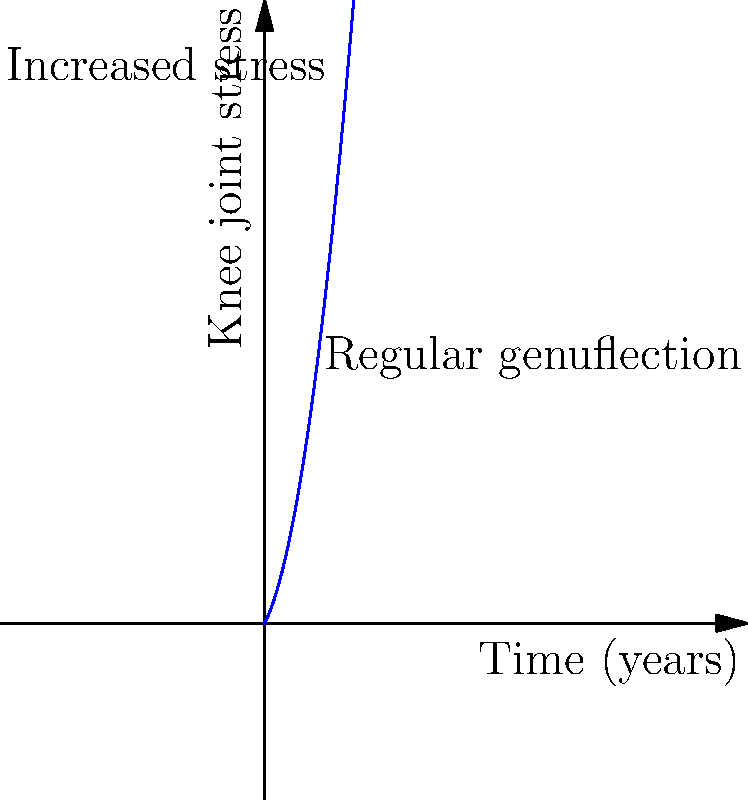Given the biomechanical stress curve of knee joints over time for individuals who regularly practice genuflection, what cognitive evolutionary explanation might account for the persistence of this potentially harmful religious practice? To answer this question, we need to consider several factors:

1. Biomechanical impact: The graph shows an increasing stress on knee joints over time due to regular genuflection. This suggests a potentially harmful physical effect.

2. Cognitive evolution: Despite the physical stress, the practice persists, indicating a possible evolutionary advantage.

3. Religious significance: Genuflection is often associated with submission, respect, and devotion in religious contexts.

4. Costly signaling theory: In evolutionary psychology, costly signaling suggests that seemingly detrimental behaviors can persist if they signal commitment to a group or belief system.

5. Group cohesion: Shared physical rituals can enhance group bonding and social cohesion.

6. Cognitive benefits: The act of genuflection might serve as a physical anchor for spiritual experiences, potentially enhancing cognitive aspects of religious practice.

7. Pain and transcendence: Some religious practices involve physical discomfort, which can be associated with transcendent experiences or perceived spiritual growth.

8. Cultural evolution: The practice may have been retained due to cultural rather than biological evolution, persisting through social learning and tradition.

Given these factors, a cognitive evolutionary explanation for the persistence of genuflection despite its physical costs could be that it serves as a costly signal of religious commitment, enhancing group cohesion and individual status within the religious community. The physical act may also serve to reinforce cognitive aspects of religious experience, potentially outweighing the long-term physical costs in terms of evolutionary fitness.
Answer: Costly signaling of religious commitment, enhancing group cohesion and reinforcing cognitive aspects of religious experience. 